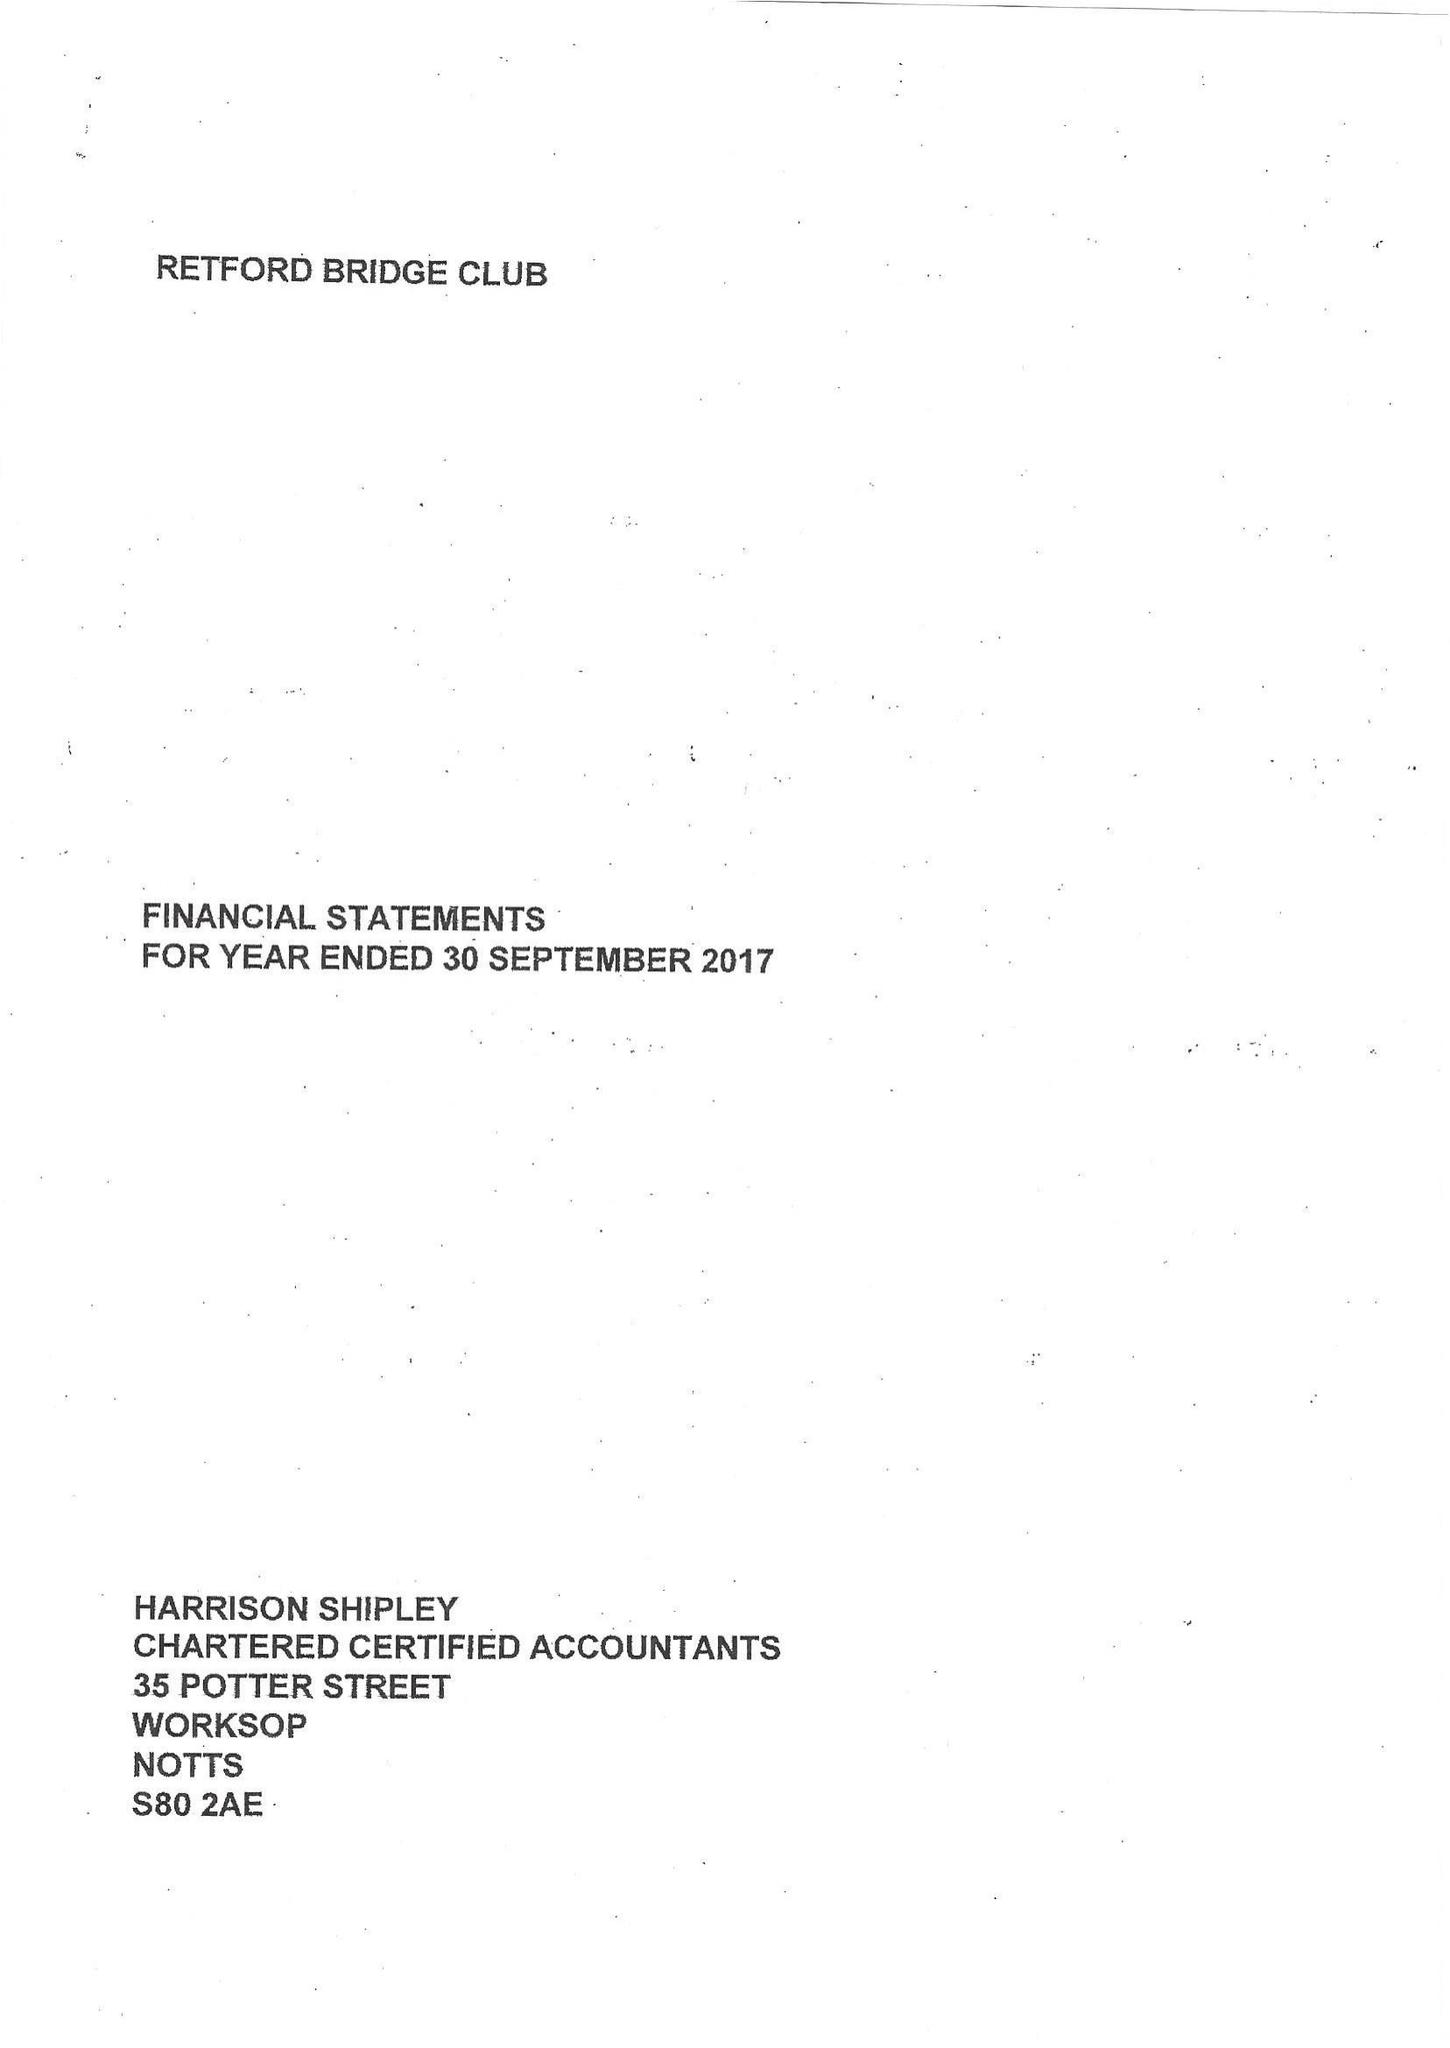What is the value for the income_annually_in_british_pounds?
Answer the question using a single word or phrase. 8146.00 